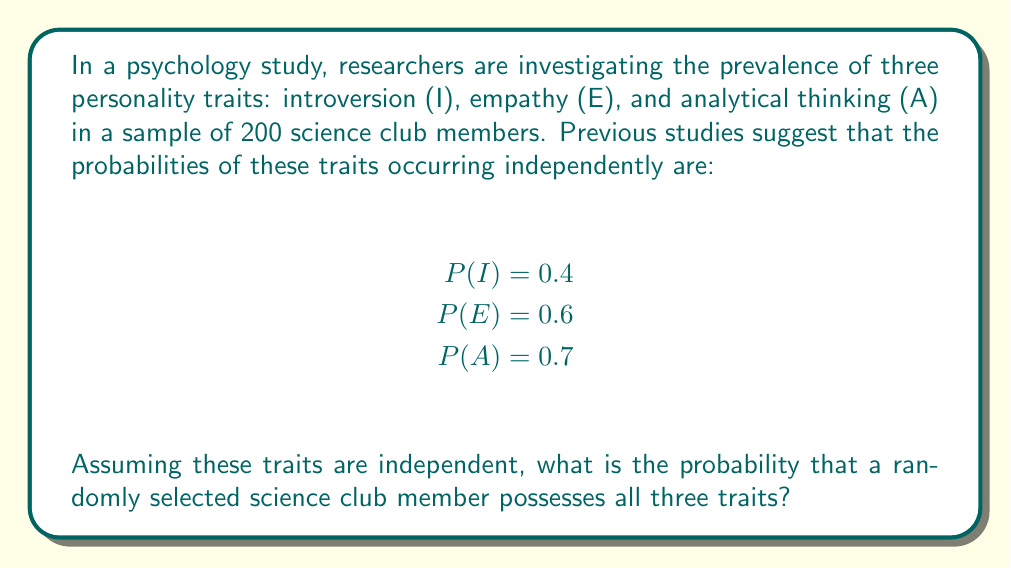Solve this math problem. To solve this problem, we need to use the multiplication rule for independent events. Since the traits are assumed to be independent, we can multiply their individual probabilities to find the probability of all three occurring together.

Let's define the event we're interested in:
$$ P(I \cap E \cap A) $$

Given:
$$ P(I) = 0.4 $$
$$ P(E) = 0.6 $$
$$ P(A) = 0.7 $$

Using the multiplication rule for independent events:

$$ P(I \cap E \cap A) = P(I) \times P(E) \times P(A) $$

Now, let's substitute the given probabilities:

$$ P(I \cap E \cap A) = 0.4 \times 0.6 \times 0.7 $$

Calculating:

$$ P(I \cap E \cap A) = 0.168 $$

To express this as a percentage:

$$ 0.168 \times 100\% = 16.8\% $$

Therefore, the probability that a randomly selected science club member possesses all three traits is 0.168 or 16.8%.
Answer: 0.168 or 16.8% 